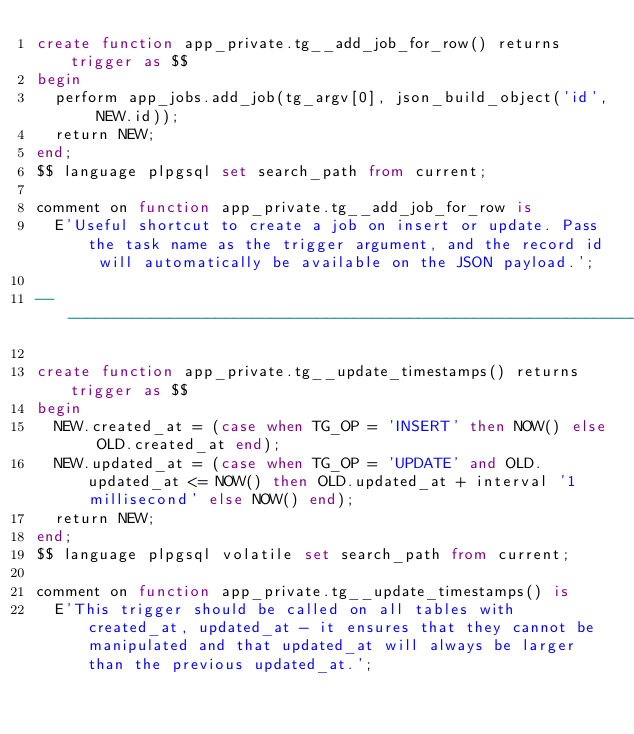<code> <loc_0><loc_0><loc_500><loc_500><_SQL_>create function app_private.tg__add_job_for_row() returns trigger as $$
begin
  perform app_jobs.add_job(tg_argv[0], json_build_object('id', NEW.id));
  return NEW;
end;
$$ language plpgsql set search_path from current;

comment on function app_private.tg__add_job_for_row is
  E'Useful shortcut to create a job on insert or update. Pass the task name as the trigger argument, and the record id will automatically be available on the JSON payload.';

--------------------------------------------------------------------------------

create function app_private.tg__update_timestamps() returns trigger as $$
begin
  NEW.created_at = (case when TG_OP = 'INSERT' then NOW() else OLD.created_at end);
  NEW.updated_at = (case when TG_OP = 'UPDATE' and OLD.updated_at <= NOW() then OLD.updated_at + interval '1 millisecond' else NOW() end);
  return NEW;
end;
$$ language plpgsql volatile set search_path from current;

comment on function app_private.tg__update_timestamps() is
  E'This trigger should be called on all tables with created_at, updated_at - it ensures that they cannot be manipulated and that updated_at will always be larger than the previous updated_at.';
</code> 